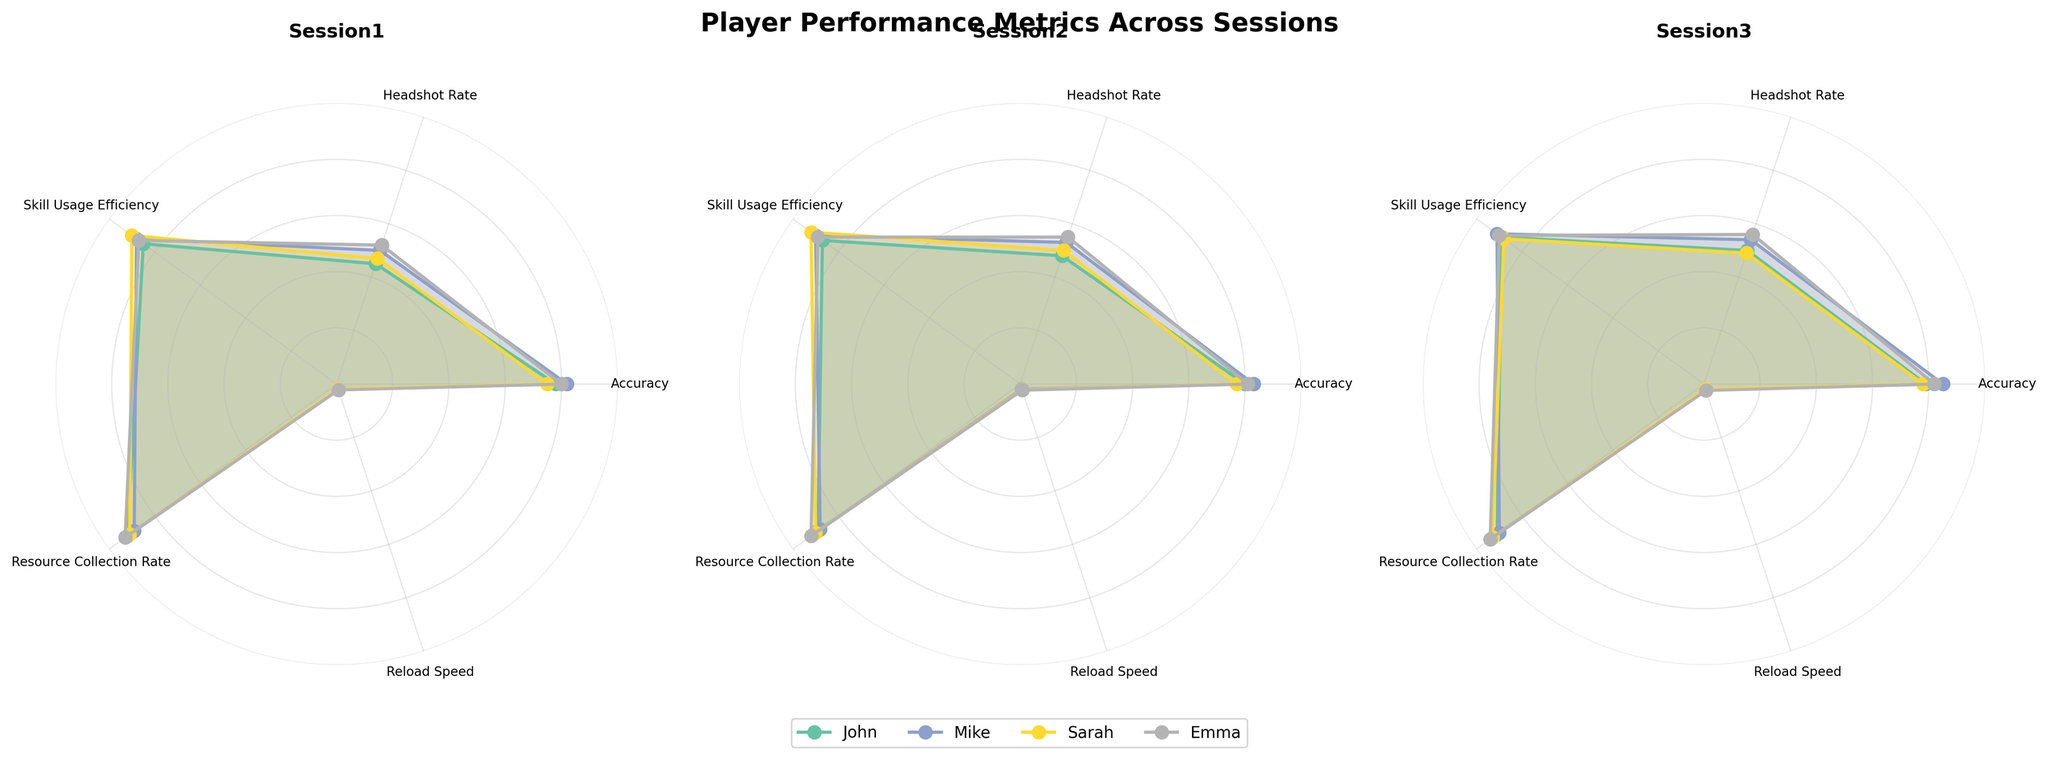What is the title of the figure? The title of the figure is usually located at the top of the plot. In this case, it should be clearly displayed there.
Answer: Player Performance Metrics Across Sessions Which player has the highest Accuracy in Session 1? By looking at the plot for Session 1, find the line representing the 'Accuracy' metric. Then compare the values for each player.
Answer: Mike How many metrics are tracked for each player? Count the number of labeled axes visible in the polar plot, which represent the different metrics.
Answer: 5 What is the difference in Skill Usage Efficiency between Mike and Sarah in Session 3? Locate the Skill Usage Efficiency values for both Mike and Sarah in Session 3 and subtract one from the other. Mike: 91, Sarah: 88. Difference = 91 - 88.
Answer: 3 Which session showed the highest Headshot Rate for Emma? Look at the polar plot for Emma across all sessions and compare the Headshot Rate values. The highest value should stand out.
Answer: Session 3 Did John's Reload Speed improve, decline, or remain constant from Session 1 to Session 3? Track John's Reload Speed values across the three sessions: Session 1: 2.1, Session 2: 2.0, Session 3: 2.2. Compare these values sequentially.
Answer: First declined, then improved Which player showed the most consistent performance in Resource Collection Rate across all sessions? Compare the Resource Collection Rate values for each player across all sessions. The most consistent will have the least variation.
Answer: John Is there a session where Sarah's Skill Usage Efficiency is higher than Emma's Skill Usage Efficiency? Compare Sarah's and Emma's Skill Usage Efficiency values for each session and identify if Sarah's value is ever higher.
Answer: Session 2 What is the average Headshot Rate for Mike across all sessions? Add Mike's Headshot Rates from all sessions and divide by the number of sessions: (50 + 53 + 54) / 3.
Answer: 52.33 Which metric has the least variation for any player in a single session? Look at each metric's range per player per session. The one with the smallest range has the least variation. Emma's Skill Usage Efficiency in Session 1, 2, 3 (87, 89, 90)
Answer: Skill Usage Efficiency for Emma 